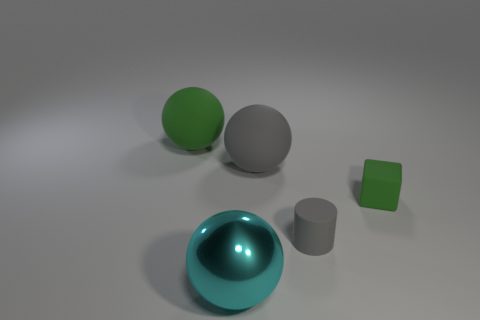Subtract all big gray balls. How many balls are left? 2 Subtract all gray spheres. How many spheres are left? 2 Subtract all cylinders. How many objects are left? 4 Add 2 tiny gray rubber objects. How many objects exist? 7 Subtract 0 yellow spheres. How many objects are left? 5 Subtract 3 balls. How many balls are left? 0 Subtract all blue spheres. Subtract all yellow cylinders. How many spheres are left? 3 Subtract all shiny spheres. Subtract all large blue cylinders. How many objects are left? 4 Add 4 tiny cylinders. How many tiny cylinders are left? 5 Add 1 purple shiny spheres. How many purple shiny spheres exist? 1 